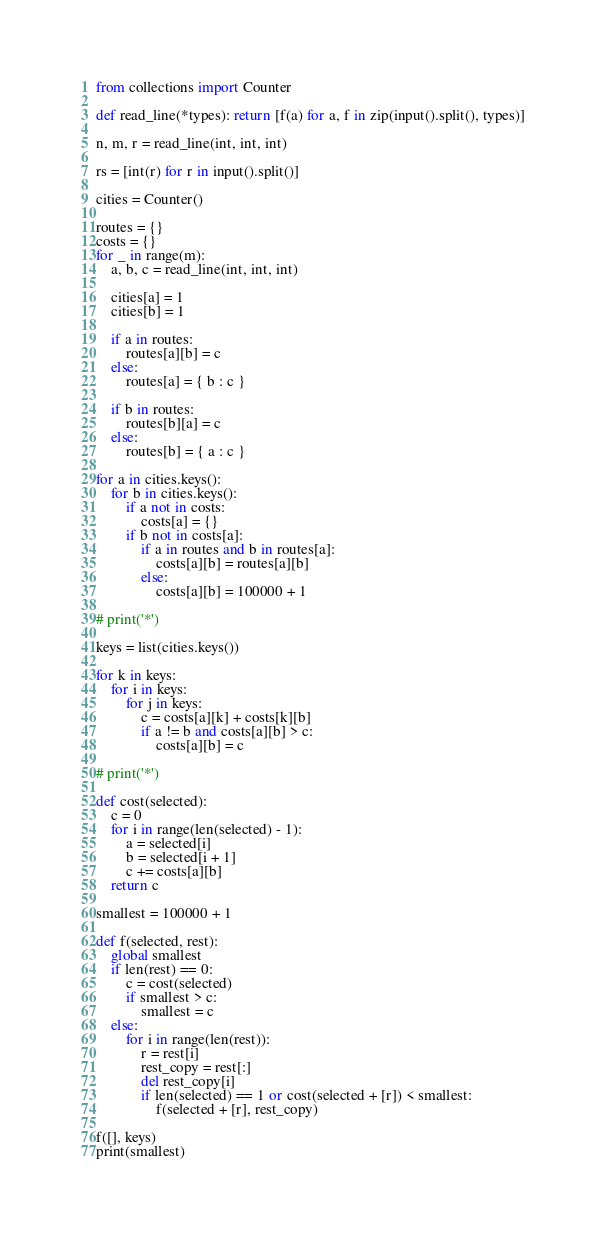Convert code to text. <code><loc_0><loc_0><loc_500><loc_500><_Python_>from collections import Counter

def read_line(*types): return [f(a) for a, f in zip(input().split(), types)]

n, m, r = read_line(int, int, int)

rs = [int(r) for r in input().split()]

cities = Counter()

routes = {}
costs = {}
for _ in range(m):
    a, b, c = read_line(int, int, int)

    cities[a] = 1
    cities[b] = 1

    if a in routes:
        routes[a][b] = c
    else:
        routes[a] = { b : c }

    if b in routes:
        routes[b][a] = c
    else:
        routes[b] = { a : c }

for a in cities.keys():
    for b in cities.keys():
        if a not in costs:
            costs[a] = {}
        if b not in costs[a]:
            if a in routes and b in routes[a]:
                costs[a][b] = routes[a][b]
            else:
                costs[a][b] = 100000 + 1

# print('*')

keys = list(cities.keys())

for k in keys:
    for i in keys:
        for j in keys:
            c = costs[a][k] + costs[k][b]
            if a != b and costs[a][b] > c:
                costs[a][b] = c

# print('*')

def cost(selected):
    c = 0
    for i in range(len(selected) - 1):
        a = selected[i]
        b = selected[i + 1]
        c += costs[a][b]
    return c

smallest = 100000 + 1

def f(selected, rest):
    global smallest
    if len(rest) == 0:
        c = cost(selected)
        if smallest > c:
            smallest = c
    else:
        for i in range(len(rest)):
            r = rest[i]
            rest_copy = rest[:]
            del rest_copy[i]
            if len(selected) == 1 or cost(selected + [r]) < smallest:
                f(selected + [r], rest_copy)

f([], keys)
print(smallest)
</code> 